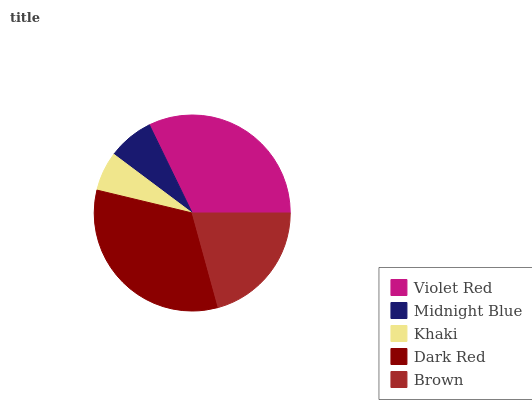Is Khaki the minimum?
Answer yes or no. Yes. Is Dark Red the maximum?
Answer yes or no. Yes. Is Midnight Blue the minimum?
Answer yes or no. No. Is Midnight Blue the maximum?
Answer yes or no. No. Is Violet Red greater than Midnight Blue?
Answer yes or no. Yes. Is Midnight Blue less than Violet Red?
Answer yes or no. Yes. Is Midnight Blue greater than Violet Red?
Answer yes or no. No. Is Violet Red less than Midnight Blue?
Answer yes or no. No. Is Brown the high median?
Answer yes or no. Yes. Is Brown the low median?
Answer yes or no. Yes. Is Khaki the high median?
Answer yes or no. No. Is Violet Red the low median?
Answer yes or no. No. 